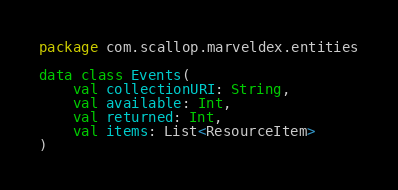Convert code to text. <code><loc_0><loc_0><loc_500><loc_500><_Kotlin_>package com.scallop.marveldex.entities

data class Events(
    val collectionURI: String,
    val available: Int,
    val returned: Int,
    val items: List<ResourceItem>
)</code> 